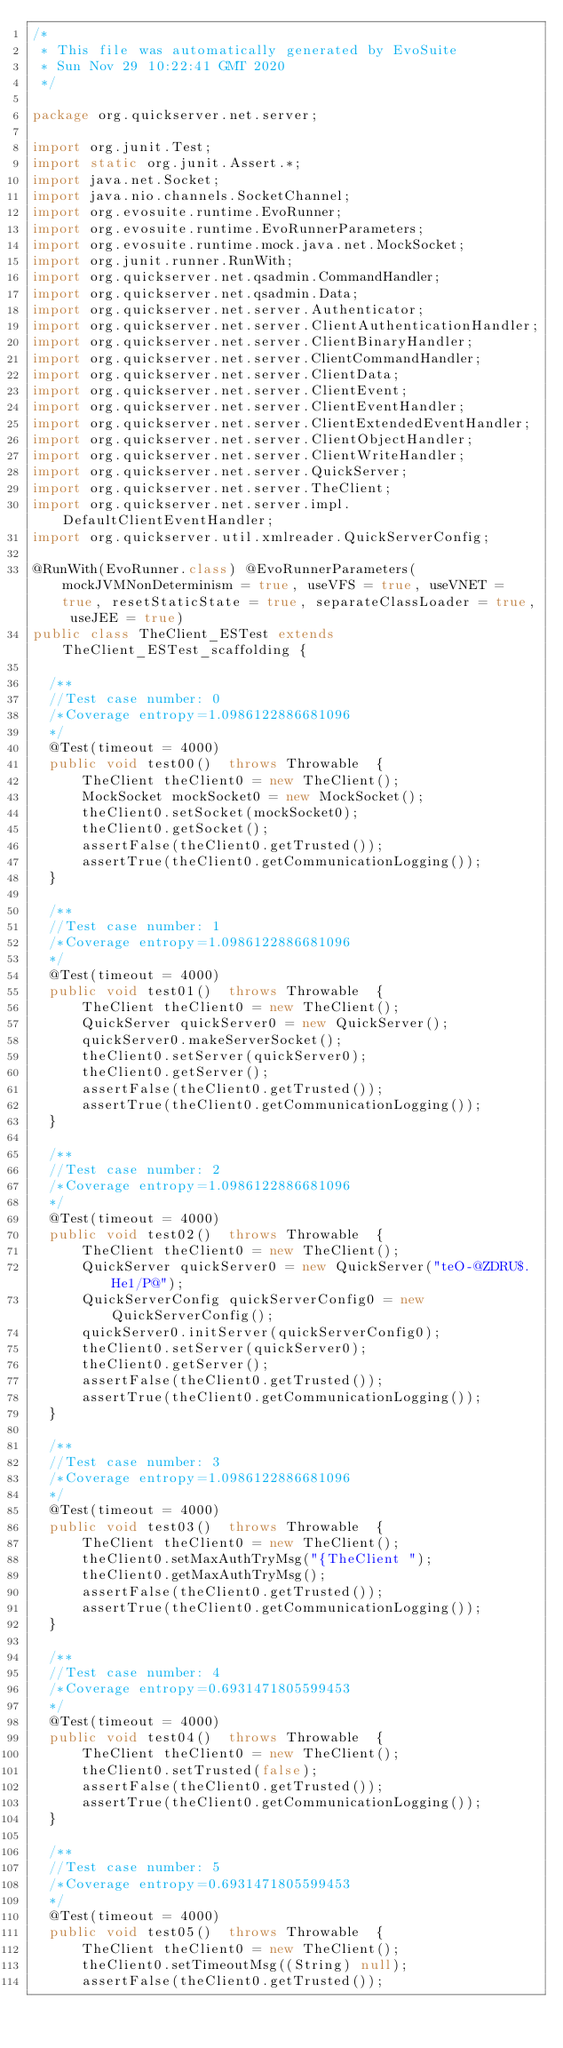<code> <loc_0><loc_0><loc_500><loc_500><_Java_>/*
 * This file was automatically generated by EvoSuite
 * Sun Nov 29 10:22:41 GMT 2020
 */

package org.quickserver.net.server;

import org.junit.Test;
import static org.junit.Assert.*;
import java.net.Socket;
import java.nio.channels.SocketChannel;
import org.evosuite.runtime.EvoRunner;
import org.evosuite.runtime.EvoRunnerParameters;
import org.evosuite.runtime.mock.java.net.MockSocket;
import org.junit.runner.RunWith;
import org.quickserver.net.qsadmin.CommandHandler;
import org.quickserver.net.qsadmin.Data;
import org.quickserver.net.server.Authenticator;
import org.quickserver.net.server.ClientAuthenticationHandler;
import org.quickserver.net.server.ClientBinaryHandler;
import org.quickserver.net.server.ClientCommandHandler;
import org.quickserver.net.server.ClientData;
import org.quickserver.net.server.ClientEvent;
import org.quickserver.net.server.ClientEventHandler;
import org.quickserver.net.server.ClientExtendedEventHandler;
import org.quickserver.net.server.ClientObjectHandler;
import org.quickserver.net.server.ClientWriteHandler;
import org.quickserver.net.server.QuickServer;
import org.quickserver.net.server.TheClient;
import org.quickserver.net.server.impl.DefaultClientEventHandler;
import org.quickserver.util.xmlreader.QuickServerConfig;

@RunWith(EvoRunner.class) @EvoRunnerParameters(mockJVMNonDeterminism = true, useVFS = true, useVNET = true, resetStaticState = true, separateClassLoader = true, useJEE = true) 
public class TheClient_ESTest extends TheClient_ESTest_scaffolding {

  /**
  //Test case number: 0
  /*Coverage entropy=1.0986122886681096
  */
  @Test(timeout = 4000)
  public void test00()  throws Throwable  {
      TheClient theClient0 = new TheClient();
      MockSocket mockSocket0 = new MockSocket();
      theClient0.setSocket(mockSocket0);
      theClient0.getSocket();
      assertFalse(theClient0.getTrusted());
      assertTrue(theClient0.getCommunicationLogging());
  }

  /**
  //Test case number: 1
  /*Coverage entropy=1.0986122886681096
  */
  @Test(timeout = 4000)
  public void test01()  throws Throwable  {
      TheClient theClient0 = new TheClient();
      QuickServer quickServer0 = new QuickServer();
      quickServer0.makeServerSocket();
      theClient0.setServer(quickServer0);
      theClient0.getServer();
      assertFalse(theClient0.getTrusted());
      assertTrue(theClient0.getCommunicationLogging());
  }

  /**
  //Test case number: 2
  /*Coverage entropy=1.0986122886681096
  */
  @Test(timeout = 4000)
  public void test02()  throws Throwable  {
      TheClient theClient0 = new TheClient();
      QuickServer quickServer0 = new QuickServer("teO@ZDRU$.He1/P@");
      QuickServerConfig quickServerConfig0 = new QuickServerConfig();
      quickServer0.initServer(quickServerConfig0);
      theClient0.setServer(quickServer0);
      theClient0.getServer();
      assertFalse(theClient0.getTrusted());
      assertTrue(theClient0.getCommunicationLogging());
  }

  /**
  //Test case number: 3
  /*Coverage entropy=1.0986122886681096
  */
  @Test(timeout = 4000)
  public void test03()  throws Throwable  {
      TheClient theClient0 = new TheClient();
      theClient0.setMaxAuthTryMsg("{TheClient ");
      theClient0.getMaxAuthTryMsg();
      assertFalse(theClient0.getTrusted());
      assertTrue(theClient0.getCommunicationLogging());
  }

  /**
  //Test case number: 4
  /*Coverage entropy=0.6931471805599453
  */
  @Test(timeout = 4000)
  public void test04()  throws Throwable  {
      TheClient theClient0 = new TheClient();
      theClient0.setTrusted(false);
      assertFalse(theClient0.getTrusted());
      assertTrue(theClient0.getCommunicationLogging());
  }

  /**
  //Test case number: 5
  /*Coverage entropy=0.6931471805599453
  */
  @Test(timeout = 4000)
  public void test05()  throws Throwable  {
      TheClient theClient0 = new TheClient();
      theClient0.setTimeoutMsg((String) null);
      assertFalse(theClient0.getTrusted());</code> 